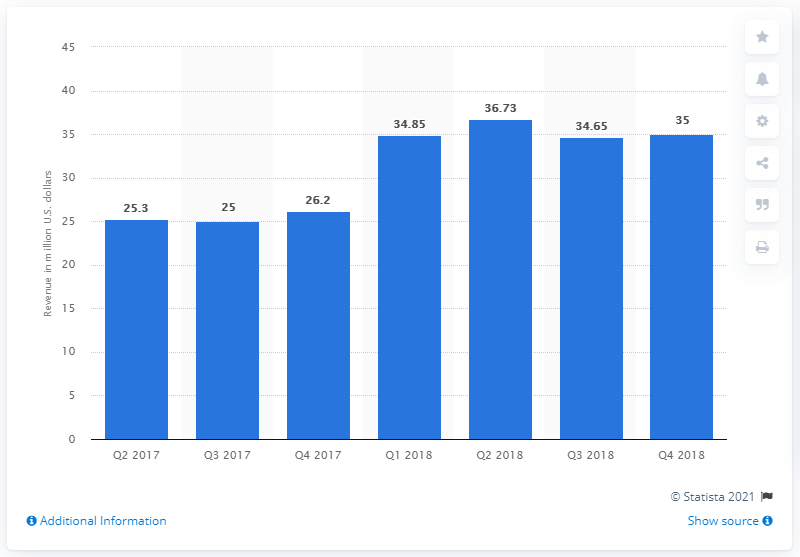Indicate a few pertinent items in this graphic. The tipping revenue in the final quarter of 2018 was $35 million. 